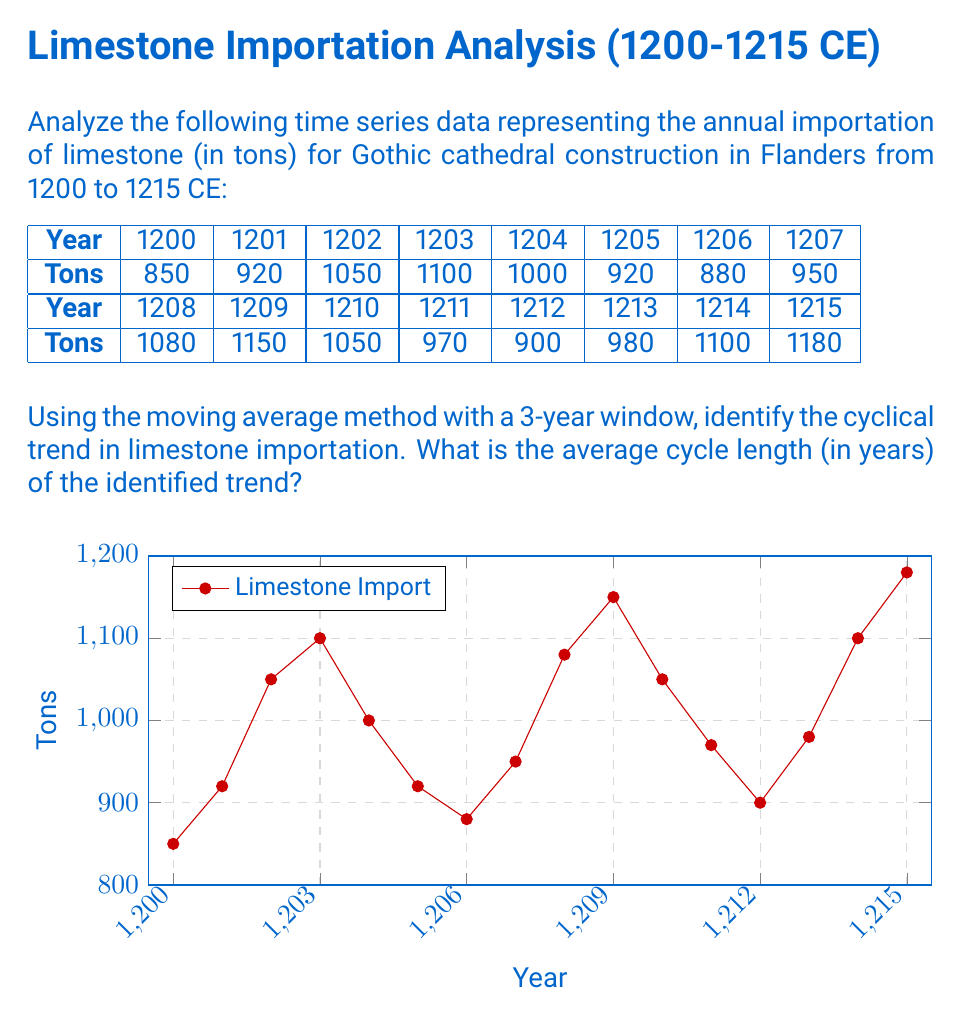Could you help me with this problem? To solve this problem, we'll follow these steps:

1) Calculate the 3-year moving average for the given data.
2) Identify the peaks and troughs in the moving average series.
3) Calculate the average distance between peaks (or troughs) to determine the cycle length.

Step 1: Calculate the 3-year moving average

For each year, we'll average the values of that year and the two preceding years. The formula is:

$$ MA_t = \frac{Y_t + Y_{t-1} + Y_{t-2}}{3} $$

Where $MA_t$ is the moving average for year $t$, and $Y_t$ is the value for year $t$.

Calculating for each year (starting from 1202):

1202: $MA_{1202} = \frac{1050 + 920 + 850}{3} = 940$
1203: $MA_{1203} = \frac{1100 + 1050 + 920}{3} = 1023.33$
...
1215: $MA_{1215} = \frac{1180 + 1100 + 980}{3} = 1086.67$

Step 2: Identify peaks and troughs

Looking at the moving average series, we can identify the following peaks and troughs:

Peaks: 1204, 1210, 1215
Troughs: 1207, 1212

Step 3: Calculate average cycle length

The distances between consecutive peaks are:
1210 - 1204 = 6 years
1215 - 1210 = 5 years

The average cycle length is:
$$ \frac{6 + 5}{2} = 5.5 \text{ years} $$

We can confirm this by looking at the distances between troughs:
1212 - 1207 = 5 years

The average of all these distances is:
$$ \frac{6 + 5 + 5}{3} = 5.33 \text{ years} $$

Rounding to the nearest whole number (as we're dealing with years), we get 5 years.
Answer: 5 years 